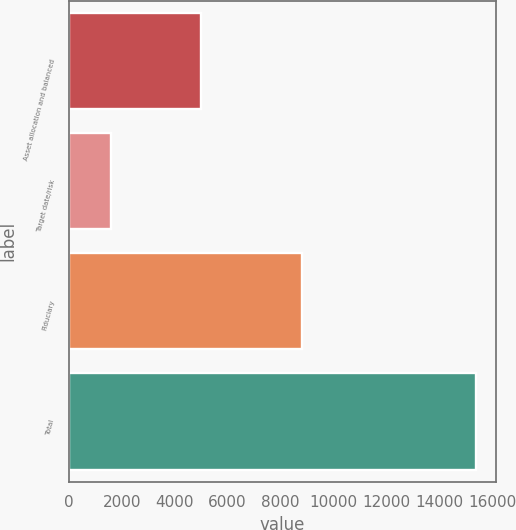Convert chart. <chart><loc_0><loc_0><loc_500><loc_500><bar_chart><fcel>Asset allocation and balanced<fcel>Target date/risk<fcel>Fiduciary<fcel>Total<nl><fcel>4985<fcel>1577<fcel>8819<fcel>15381<nl></chart> 